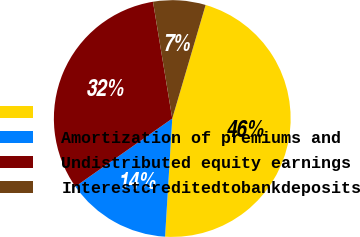Convert chart to OTSL. <chart><loc_0><loc_0><loc_500><loc_500><pie_chart><ecel><fcel>Amortization of premiums and<fcel>Undistributed equity earnings<fcel>Interestcreditedtobankdeposits<nl><fcel>46.42%<fcel>14.29%<fcel>32.14%<fcel>7.15%<nl></chart> 